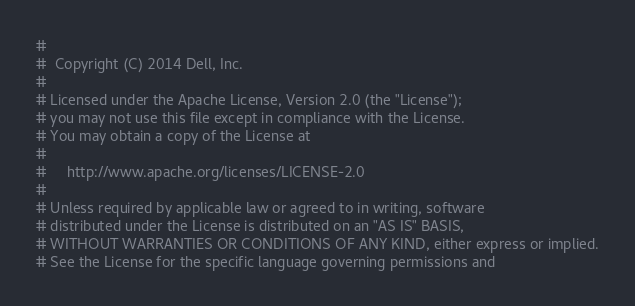<code> <loc_0><loc_0><loc_500><loc_500><_Python_>#
#  Copyright (C) 2014 Dell, Inc.
#
# Licensed under the Apache License, Version 2.0 (the "License");
# you may not use this file except in compliance with the License.
# You may obtain a copy of the License at
#
#     http://www.apache.org/licenses/LICENSE-2.0
#
# Unless required by applicable law or agreed to in writing, software
# distributed under the License is distributed on an "AS IS" BASIS,
# WITHOUT WARRANTIES OR CONDITIONS OF ANY KIND, either express or implied.
# See the License for the specific language governing permissions and</code> 